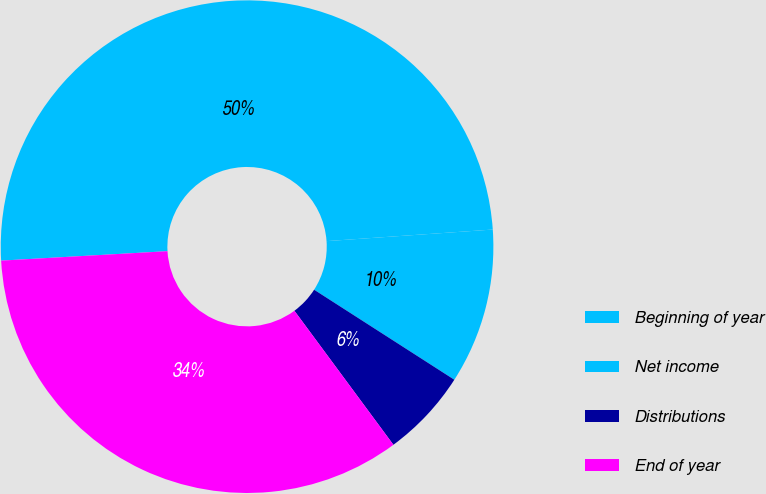Convert chart to OTSL. <chart><loc_0><loc_0><loc_500><loc_500><pie_chart><fcel>Beginning of year<fcel>Net income<fcel>Distributions<fcel>End of year<nl><fcel>49.79%<fcel>10.19%<fcel>5.79%<fcel>34.22%<nl></chart> 